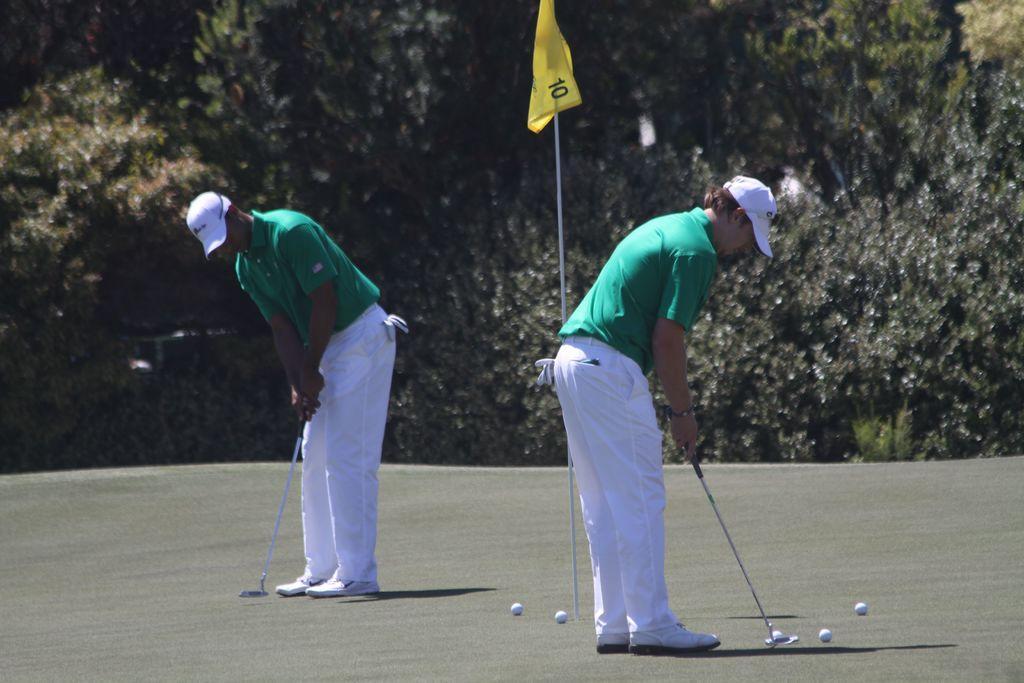How would you summarize this image in a sentence or two? There are two persons wearing cap and holding golf sticks. On the ground there are balls. Also there is a flag with a pole. In the background there are trees. 